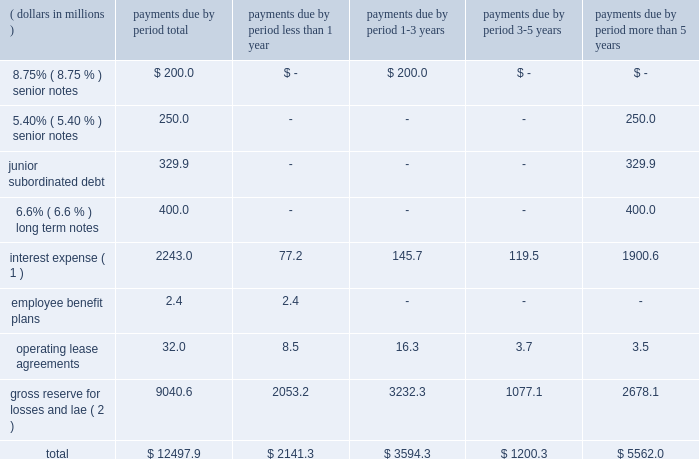Contractual obligations .
The table shows our contractual obligations for the period indicated: .
( 1 ) interest expense on 6.6% ( 6.6 % ) long term notes is assumed to be fixed through contractual term .
( 2 ) loss and lae reserves represent our best estimate of losses from claim and related settlement costs .
Both the amounts and timing of such payments are estimates , and the inherent variability of resolving claims as well as changes in market conditions make the timing of cash flows uncertain .
Therefore , the ultimate amount and timing of loss and lae payments could differ from our estimates .
The contractual obligations for senior notes , long term notes and junior subordinated debt are the responsibility of holdings .
We have sufficient cash flow , liquidity , investments and access to capital markets to satisfy these obligations .
Holdings gen- erally depends upon dividends from everest re , its operating insurance subsidiary for its funding , capital contributions from group or access to the capital markets .
Our various operating insurance and reinsurance subsidiaries have sufficient cash flow , liquidity and investments to settle outstanding reserves for losses and lae .
Management believes that we , and each of our entities , have sufficient financial resources or ready access thereto , to meet all obligations .
Dividends .
During 2007 , 2006 and 2005 , we declared and paid shareholder dividends of $ 121.4 million , $ 39.0 million and $ 25.4 million , respectively .
As an insurance holding company , we are partially dependent on dividends and other permitted pay- ments from our subsidiaries to pay cash dividends to our shareholders .
The payment of dividends to group by holdings and to holdings by everest re is subject to delaware regulatory restrictions and the payment of dividends to group by bermuda re is subject to bermuda insurance regulatory restrictions .
Management expects that , absent extraordinary catastrophe losses , such restrictions should not affect everest re 2019s ability to declare and pay dividends sufficient to support holdings 2019 general corporate needs and that holdings and bermuda re will have the ability to declare and pay dividends sufficient to support group 2019s general corporate needs .
For the years ended december 31 , 2007 , 2006 and 2005 , everest re paid divi- dends to holdings of $ 245.0 million , $ 100.0 million and $ 75.0 million , respectively .
For the years ended december 31 , 2007 , 2006 and 2005 , bermuda re paid dividends to group of $ 0.0 million , $ 60.0 million and $ 45.0 million , respectively .
See item 1 , 201cbusiness 2013 regulatory matters 2013 dividends 201d and note 16 of notes to consolidated financial statements .
Application of new accounting standards .
In november 2005 , the fasb issued fasb staff position ( 201cfsp 201d ) fas 115-1 , 201cthe meaning of other-than-temporary impairment and its application to certain investments 201d ( 201cfas 115-1 201d ) , which is effective for reporting periods beginning after december 15 , 2005 .
Fas 115-1 addresses the determination as to when an investment is considered impaired , whether the impairment is other than temporary and the measurement of an impairment loss .
Fas 115-1 also includes accounting considerations subsequent to the recognition of an other-than-temporary impairment and requires certain dis- closures about unrealized losses not recognized as other-than-temporary impairments .
The company adopted fas 115-1 prospectively effective january 1 , 2006 .
The company believes that all unrealized losses in its investment portfolio are temporary in nature. .
What was the rate of increase in 2007 shareholder dividends paid? 
Computations: ((121.4 - 39.0) / 39.0)
Answer: 2.11282. 